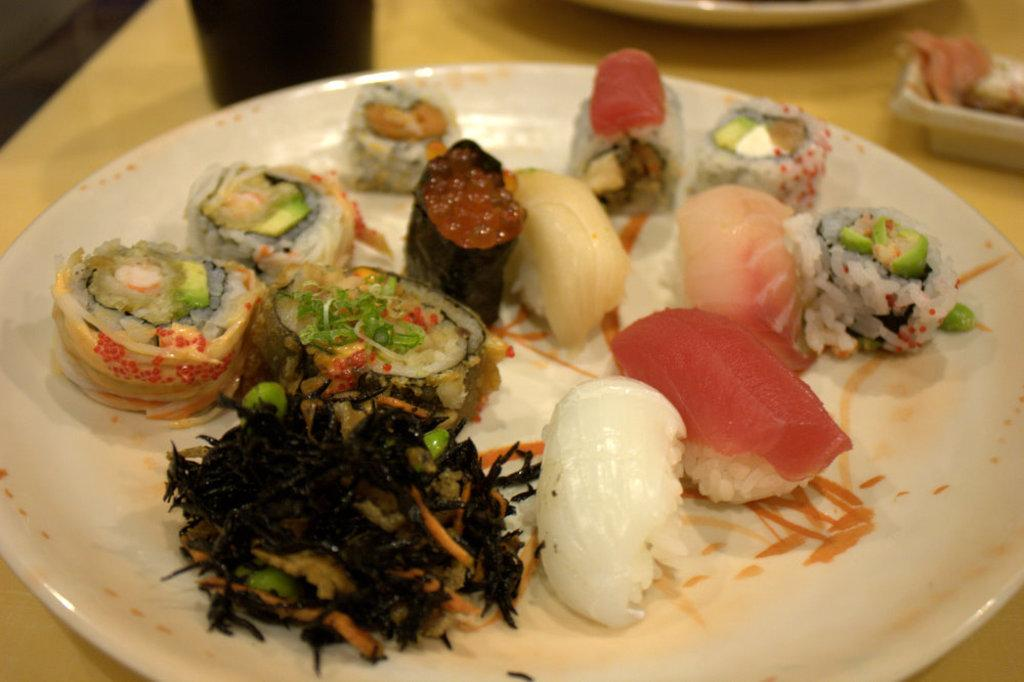What is the main object in the center of the image? There is a table in the center of the image. What is placed on the table? There are food items on a plate on the table. What type of cars can be seen driving by at night in the image? There are no cars or any indication of nighttime in the image; it only features a table with food items on a plate. 